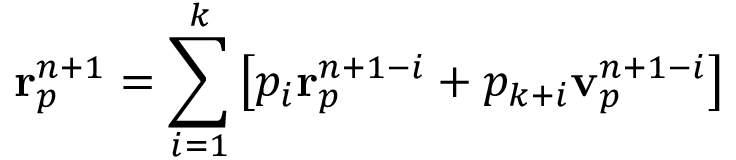Convert formula to latex. <formula><loc_0><loc_0><loc_500><loc_500>r _ { p } ^ { n + 1 } = \sum _ { i = 1 } ^ { k } \left [ p _ { i } r _ { p } ^ { n + 1 - i } + p _ { k + i } v _ { p } ^ { n + 1 - i } \right ]</formula> 